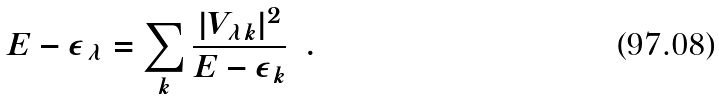<formula> <loc_0><loc_0><loc_500><loc_500>E - \epsilon _ { \lambda } = \sum _ { k } \frac { | V _ { \lambda k } | ^ { 2 } } { E - \epsilon _ { k } } \ \ .</formula> 